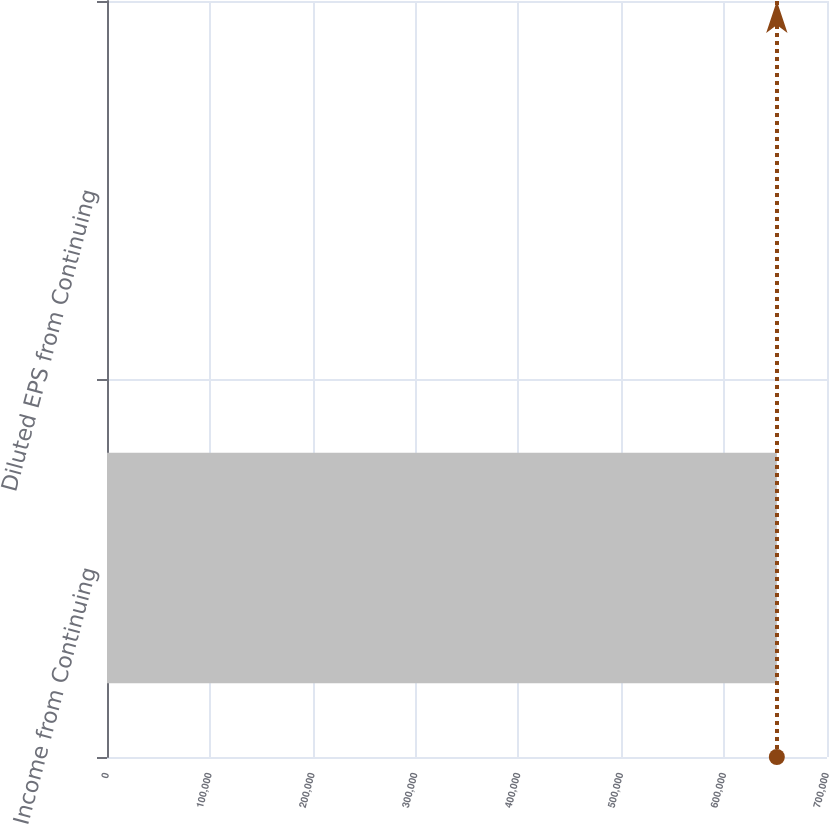<chart> <loc_0><loc_0><loc_500><loc_500><bar_chart><fcel>Income from Continuing<fcel>Diluted EPS from Continuing<nl><fcel>651236<fcel>2.13<nl></chart> 